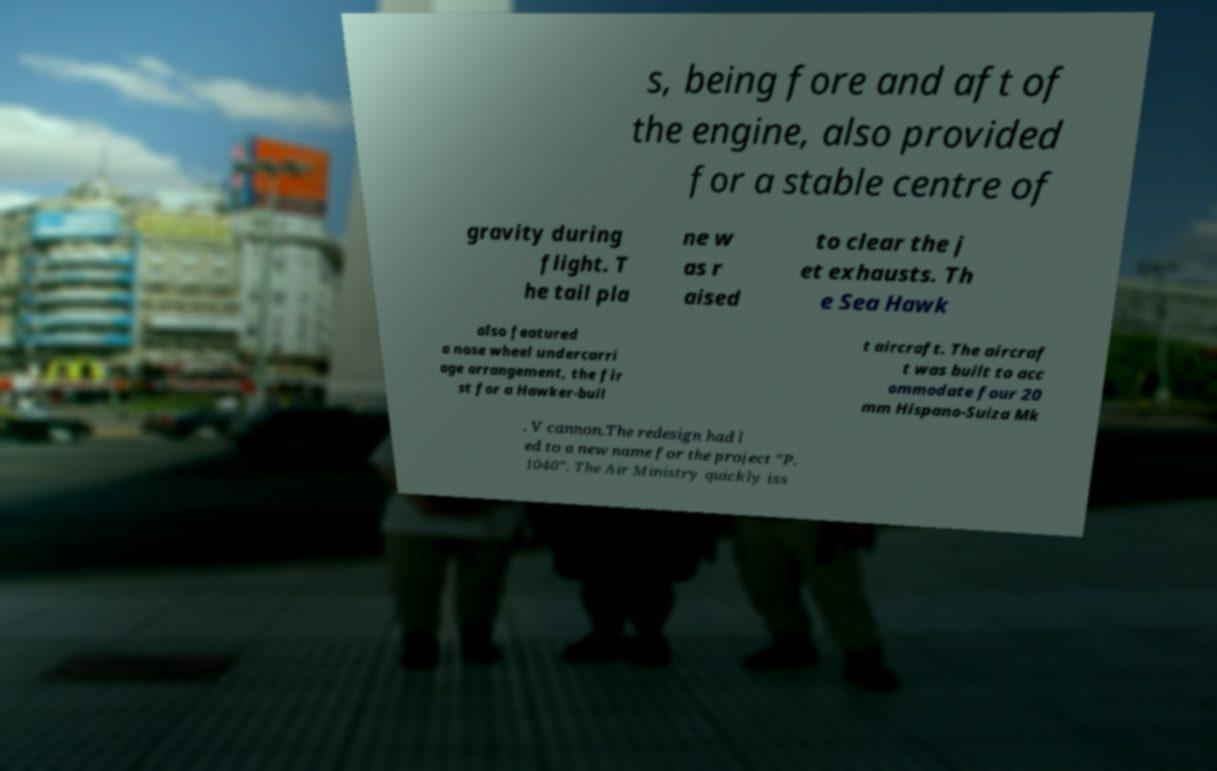There's text embedded in this image that I need extracted. Can you transcribe it verbatim? s, being fore and aft of the engine, also provided for a stable centre of gravity during flight. T he tail pla ne w as r aised to clear the j et exhausts. Th e Sea Hawk also featured a nose wheel undercarri age arrangement, the fir st for a Hawker-buil t aircraft. The aircraf t was built to acc ommodate four 20 mm Hispano-Suiza Mk . V cannon.The redesign had l ed to a new name for the project "P. 1040". The Air Ministry quickly iss 